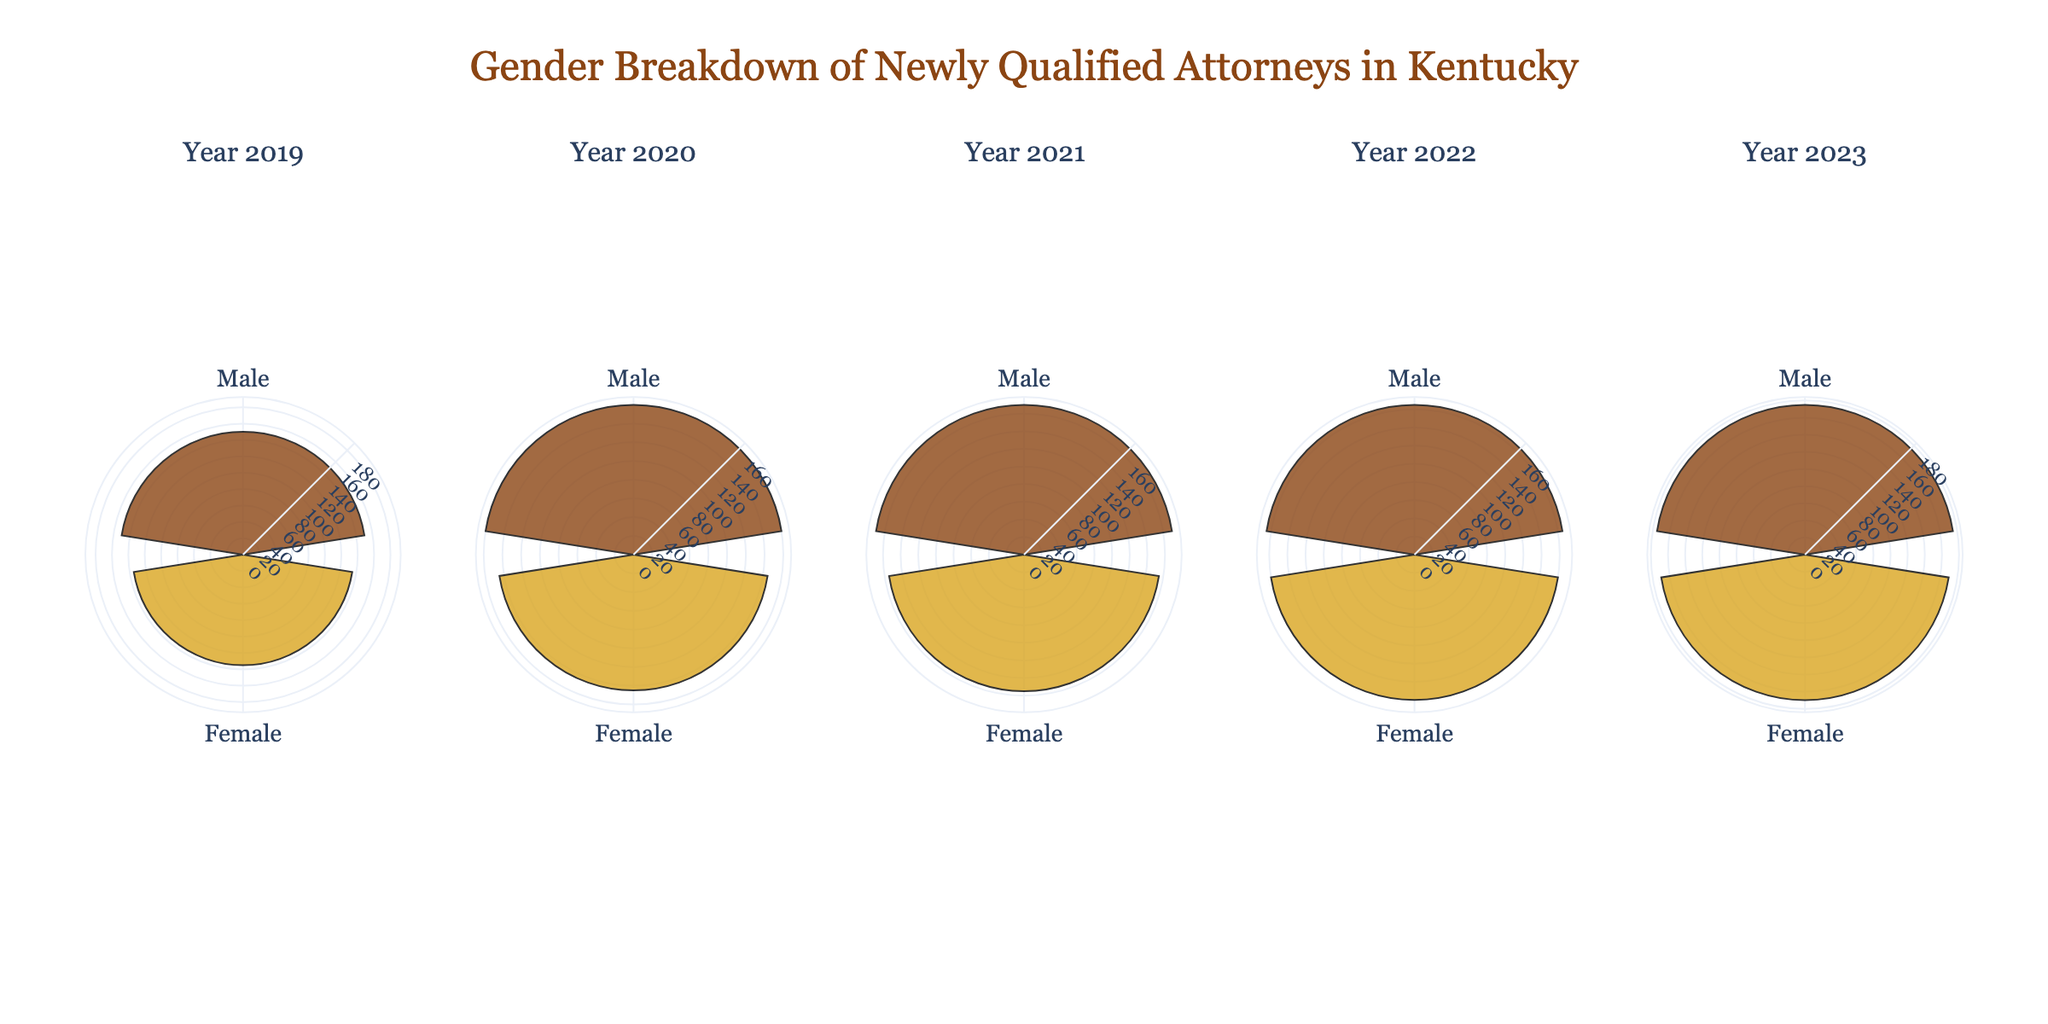What year has the highest number of newly qualified female attorneys? To find the year with the highest number of newly qualified female attorneys, look at all the subplots for each year and compare the radial values for the "Female" category. The highest value for females is in the subplot for the year 2023, with 170.
Answer: 2023 How many newly qualified attorneys were there in 2020? Sum the values for both genders in the subplot for 2020. There are 160 males and 145 females. Summing these values gives 160 + 145 = 305.
Answer: 305 Which year saw a decrease in the number of newly qualified male attorneys compared to the previous year? Examine each year's subplot for the male category, and compare values year by year. By comparing, 2021 had 170, while 2022 had 165, indicating a decrease from 2021 to 2022.
Answer: 2022 What is the combined number of newly qualified male attorneys in 2019 and 2023? Check the subplots for 2019 and 2023, then sum the values for the male category in these years. 2019 has 150 males, and 2023 has 175 males, so 150 + 175 = 325.
Answer: 325 Which gender had the smallest increase in numbers from 2019 to 2023? Look at the difference in radial values between 2019 and 2023 for both gender categories. Males increased from 150 to 175, which is an increase of 25. Females increased from 135 to 170, which is an increase of 35. The smallest increase is for males.
Answer: Male 